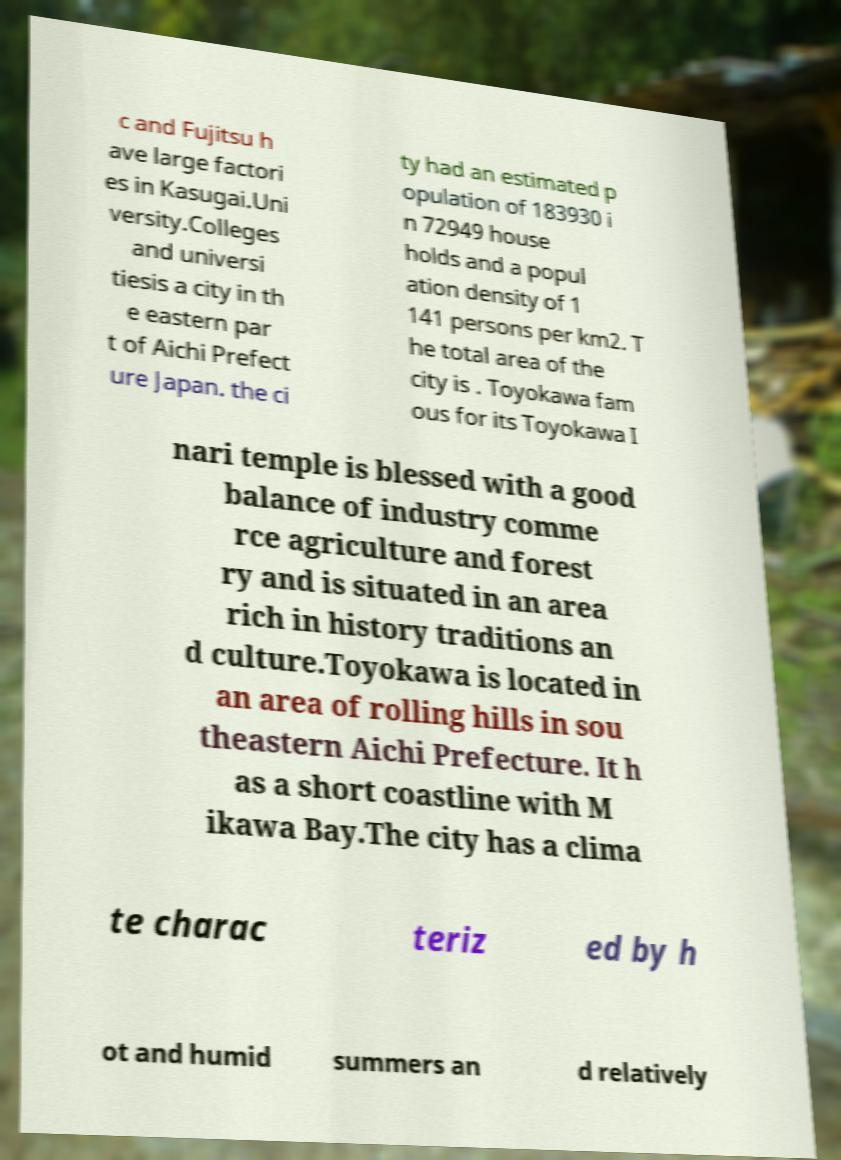Can you accurately transcribe the text from the provided image for me? c and Fujitsu h ave large factori es in Kasugai.Uni versity.Colleges and universi tiesis a city in th e eastern par t of Aichi Prefect ure Japan. the ci ty had an estimated p opulation of 183930 i n 72949 house holds and a popul ation density of 1 141 persons per km2. T he total area of the city is . Toyokawa fam ous for its Toyokawa I nari temple is blessed with a good balance of industry comme rce agriculture and forest ry and is situated in an area rich in history traditions an d culture.Toyokawa is located in an area of rolling hills in sou theastern Aichi Prefecture. It h as a short coastline with M ikawa Bay.The city has a clima te charac teriz ed by h ot and humid summers an d relatively 